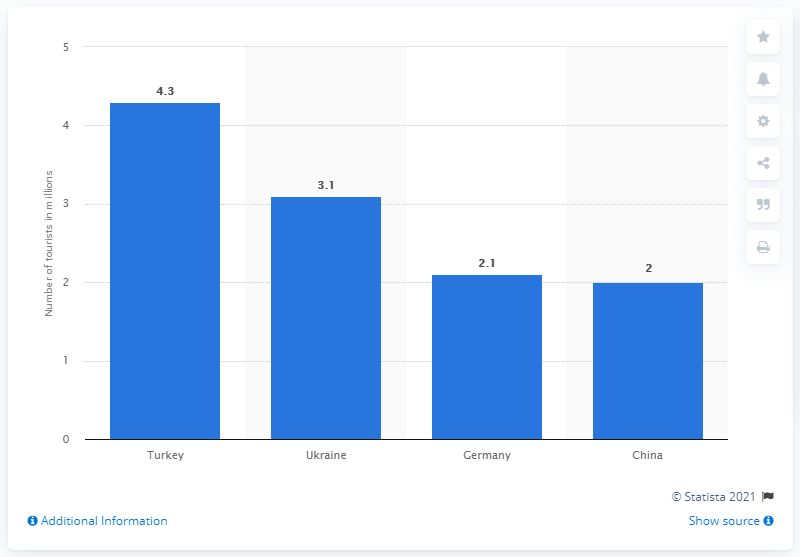Identify some key points in this picture. In 2013, 4,300 Russians traveled to Turkey. The most popular destination for Russian tourists in 2013 was Turkey. 